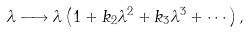Convert formula to latex. <formula><loc_0><loc_0><loc_500><loc_500>\lambda \longrightarrow \lambda \left ( 1 + k _ { 2 } \lambda ^ { 2 } + k _ { 3 } \lambda ^ { 3 } + \cdots \right ) ,</formula> 